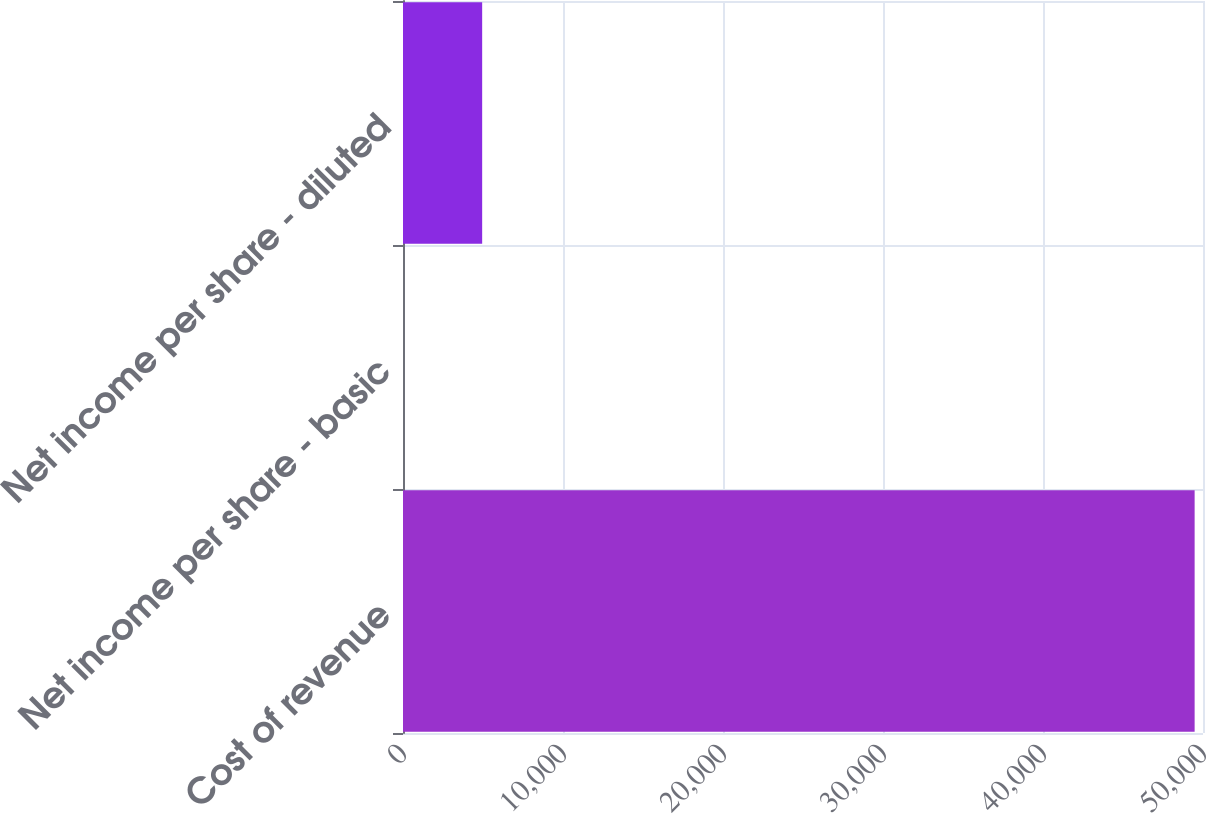<chart> <loc_0><loc_0><loc_500><loc_500><bar_chart><fcel>Cost of revenue<fcel>Net income per share - basic<fcel>Net income per share - diluted<nl><fcel>49477<fcel>0.13<fcel>4947.82<nl></chart> 